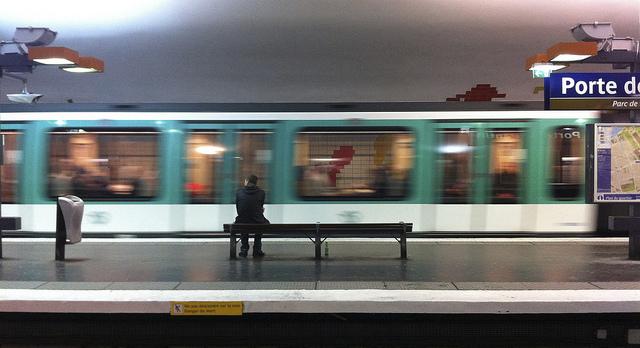Is the train moving or still?
Write a very short answer. Moving. How many people are on the bench?
Write a very short answer. 1. What color are the doors?
Be succinct. Green. What is in motion?
Write a very short answer. Train. 